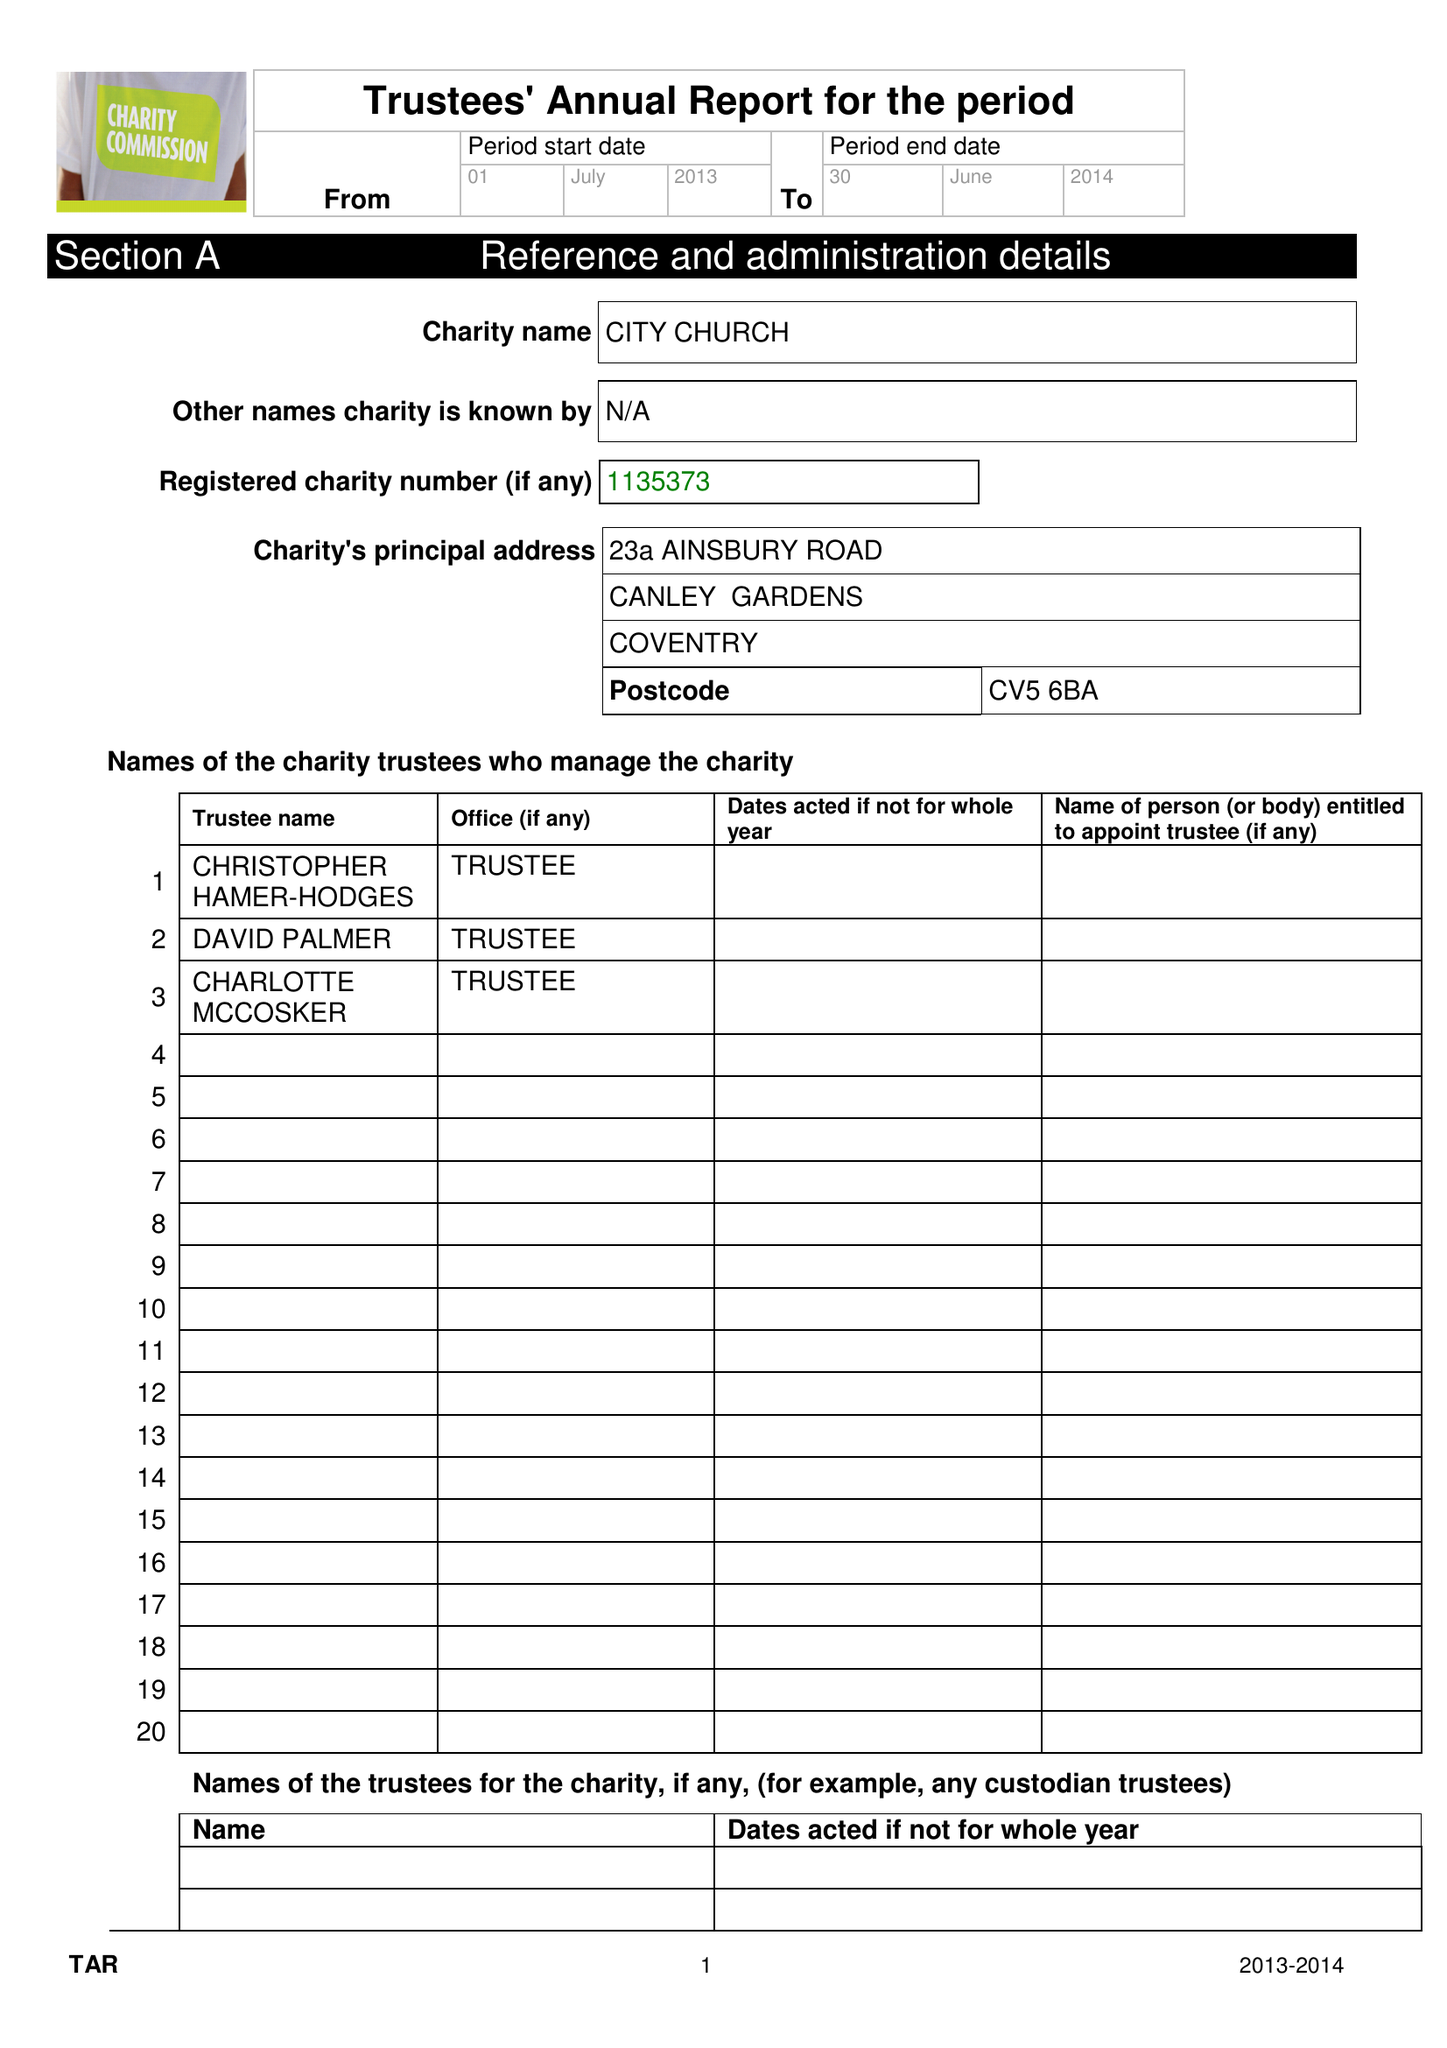What is the value for the report_date?
Answer the question using a single word or phrase. 2014-06-30 